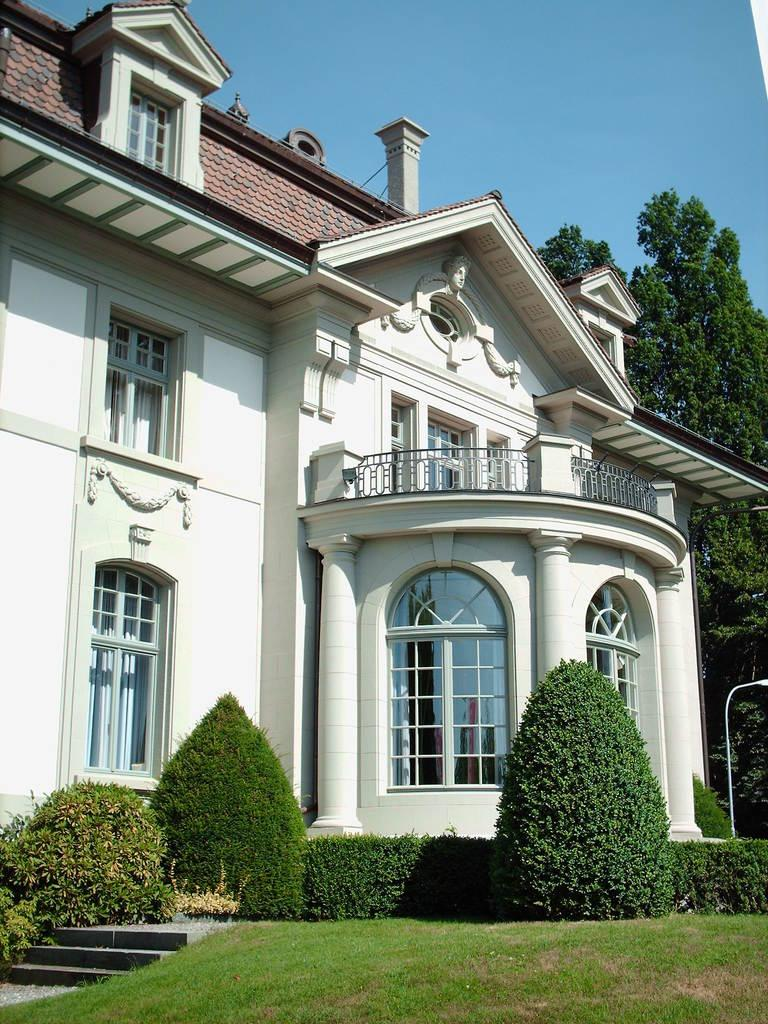What type of structure is visible in the image? There is a building in the image. What other elements can be seen in the image besides the building? There are plants, grass, stairs, trees, and the sky visible in the image. Where are the stairs located in relation to the building? The stairs are in front of the building. What type of vegetation is present in the background of the image? There are trees in the background of the image. What is visible at the top of the image? The sky is visible in the background of the image. What type of furniture can be seen in the image? There is no furniture present in the image. How many marbles are visible in the image? There are no marbles present in the image. 